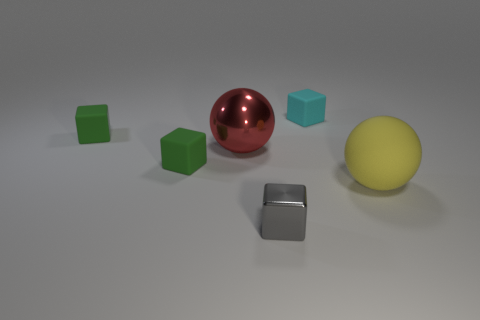How many objects are in the image, and can you describe their shapes and colors? There are five objects in the image. Starting from the left, there are three green cubes, a shiny red sphere, a metallic grey cube, and finally, a matte yellow sphere. Which object is closest to the camera? The tiny cyan cube appears to be closest to the camera. 